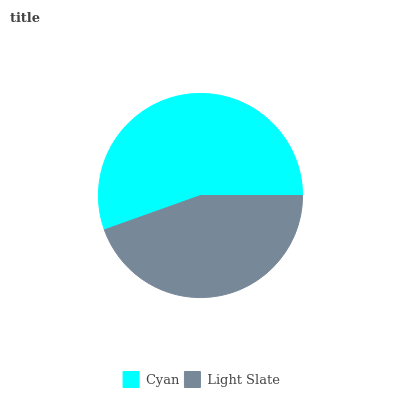Is Light Slate the minimum?
Answer yes or no. Yes. Is Cyan the maximum?
Answer yes or no. Yes. Is Light Slate the maximum?
Answer yes or no. No. Is Cyan greater than Light Slate?
Answer yes or no. Yes. Is Light Slate less than Cyan?
Answer yes or no. Yes. Is Light Slate greater than Cyan?
Answer yes or no. No. Is Cyan less than Light Slate?
Answer yes or no. No. Is Cyan the high median?
Answer yes or no. Yes. Is Light Slate the low median?
Answer yes or no. Yes. Is Light Slate the high median?
Answer yes or no. No. Is Cyan the low median?
Answer yes or no. No. 